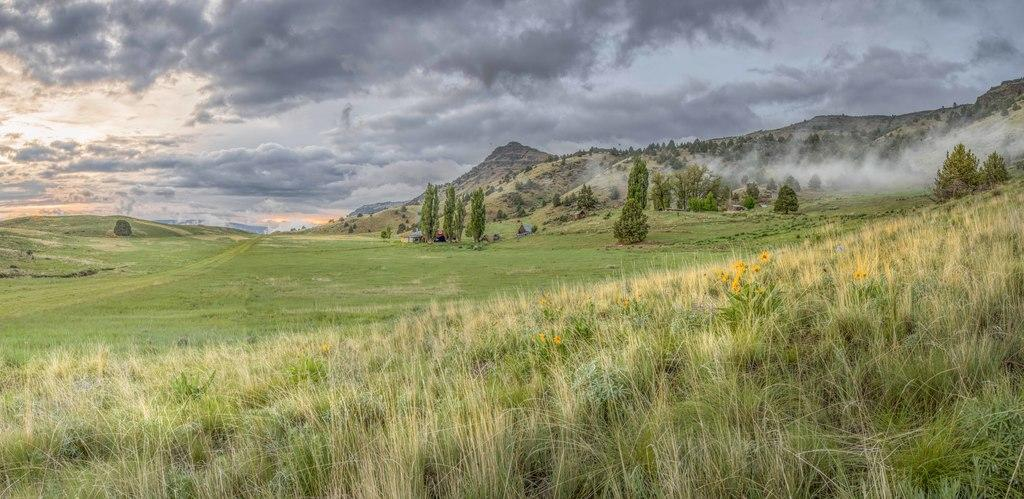What type of natural landscape can be seen in the background of the image? There are mountains in the background of the image. What type of vegetation is present in the image? There are trees and grass in the image. What is visible at the top of the image? The sky is visible at the top of the image. What can be observed in the sky? Clouds are present in the sky. How does the bottle affect the wind in the image? There is no bottle present in the image, so it cannot affect the wind. 